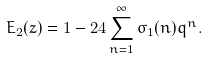<formula> <loc_0><loc_0><loc_500><loc_500>E _ { 2 } ( z ) = 1 - 2 4 \sum _ { n = 1 } ^ { \infty } \sigma _ { 1 } ( n ) q ^ { n } .</formula> 